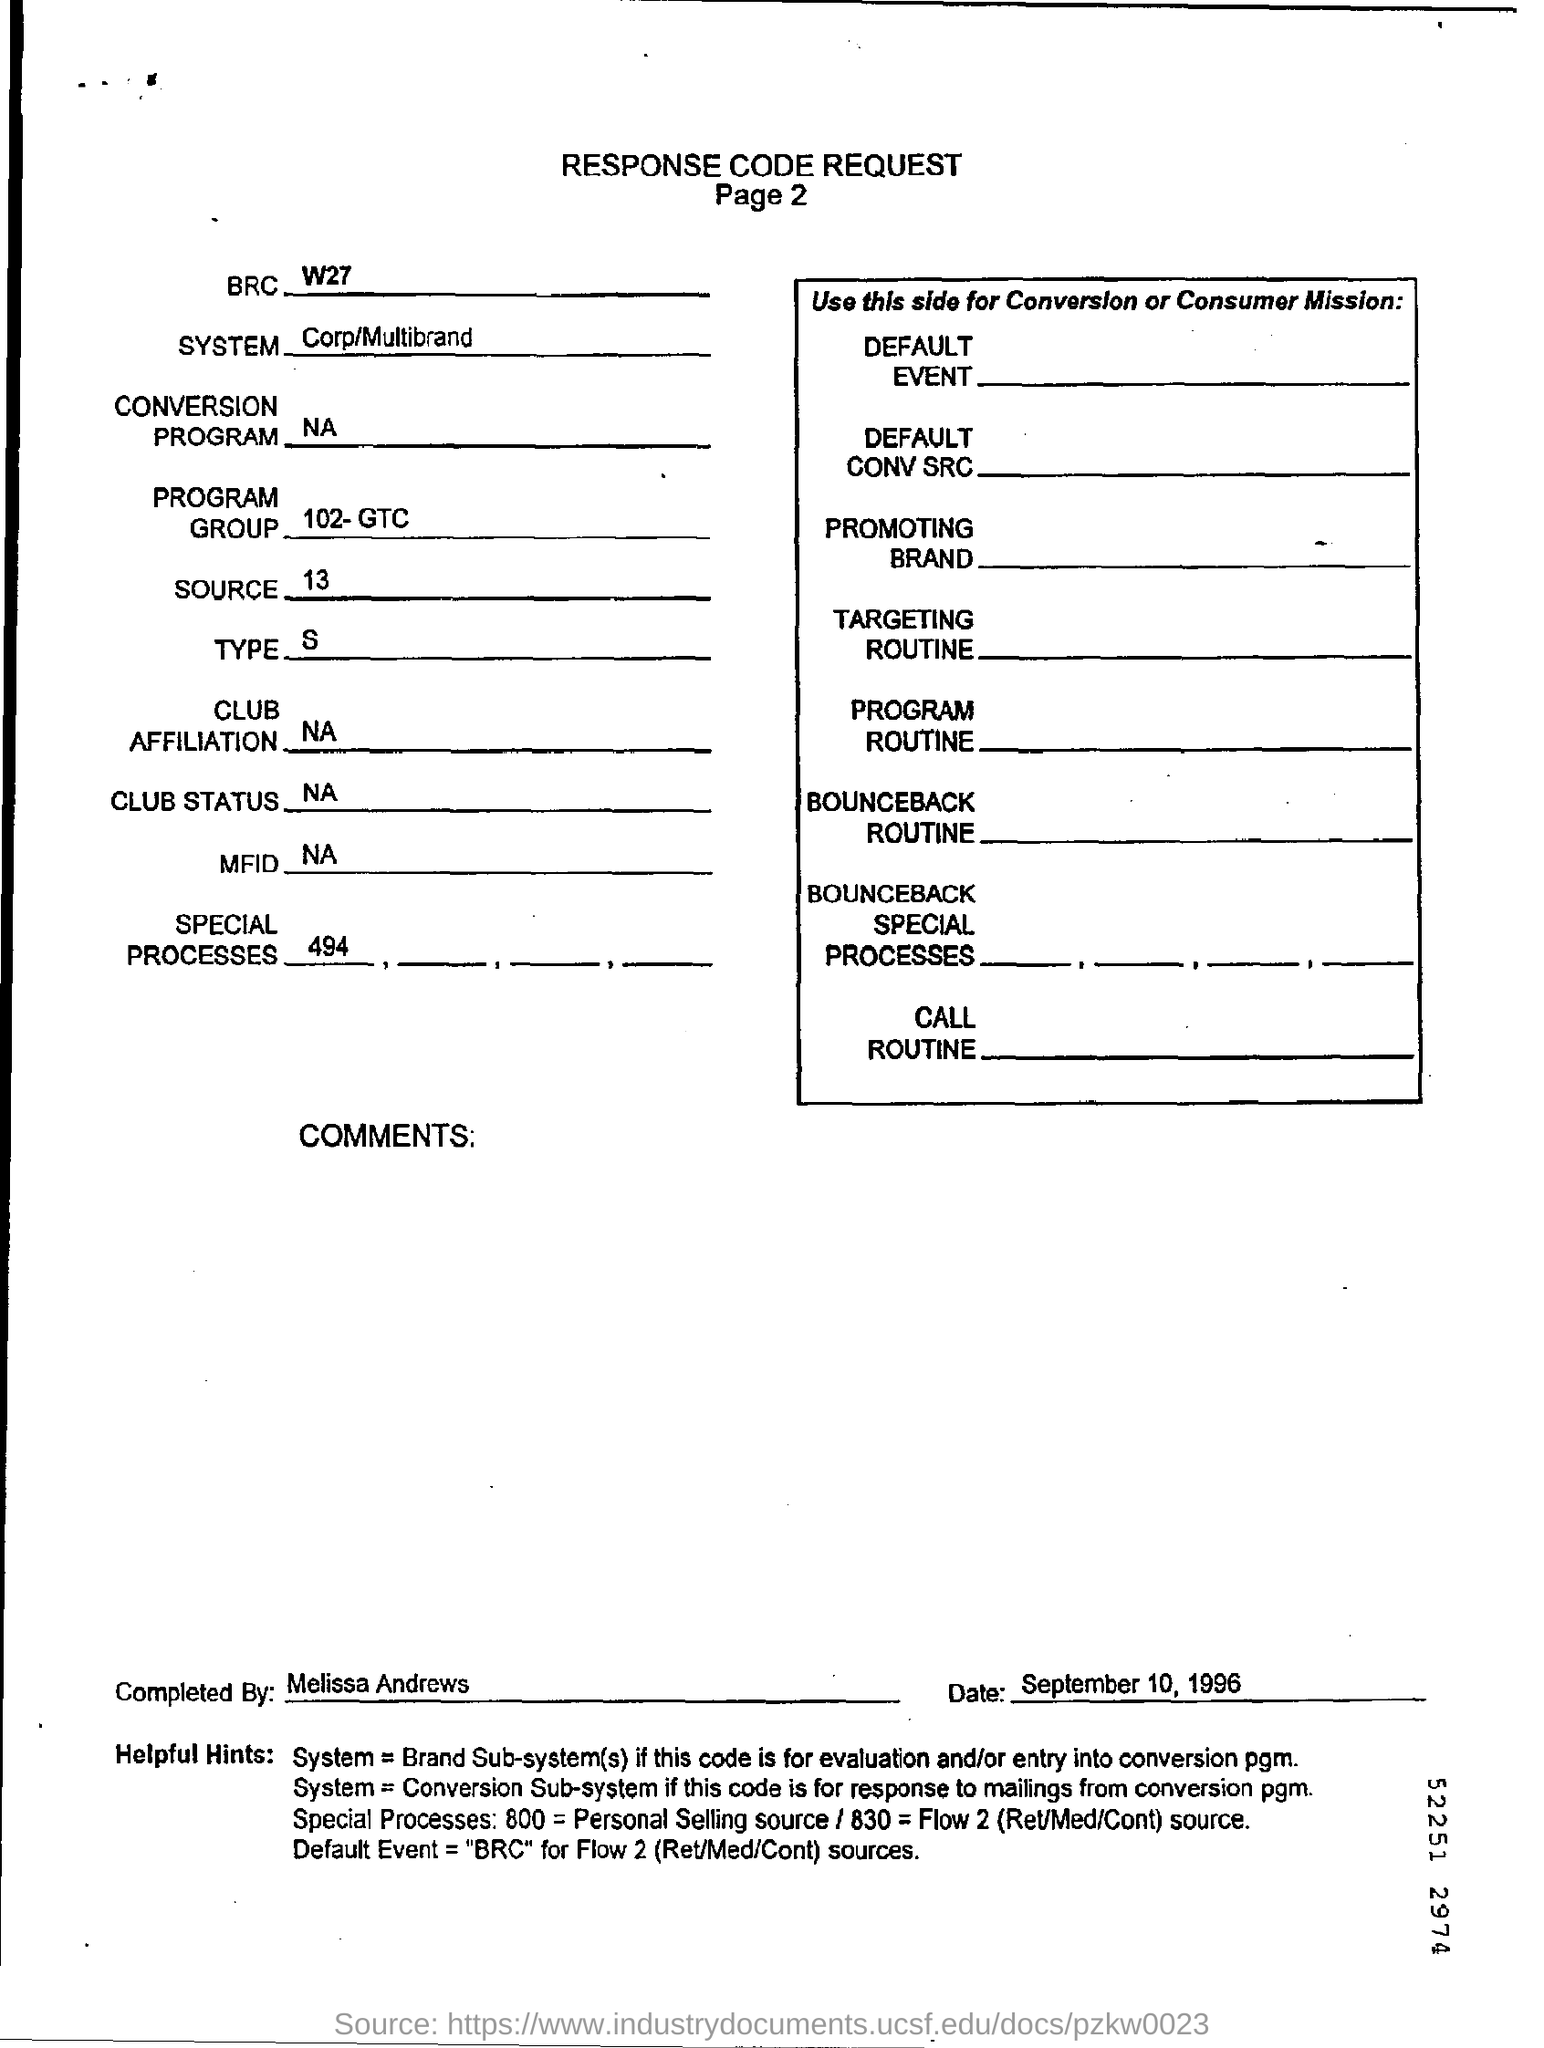What is the date printed on the form?
Your answer should be very brief. September 10, 1996. Who completed this form?
Your answer should be compact. Melissa Andrews. What is the system name?
Offer a terse response. Corp/Multibrand. 